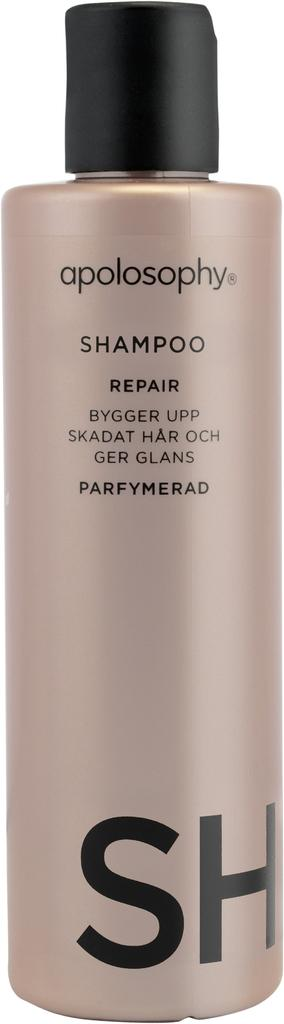<image>
Present a compact description of the photo's key features. Apolosophy by SH hair repair shampoo in beige bottle 